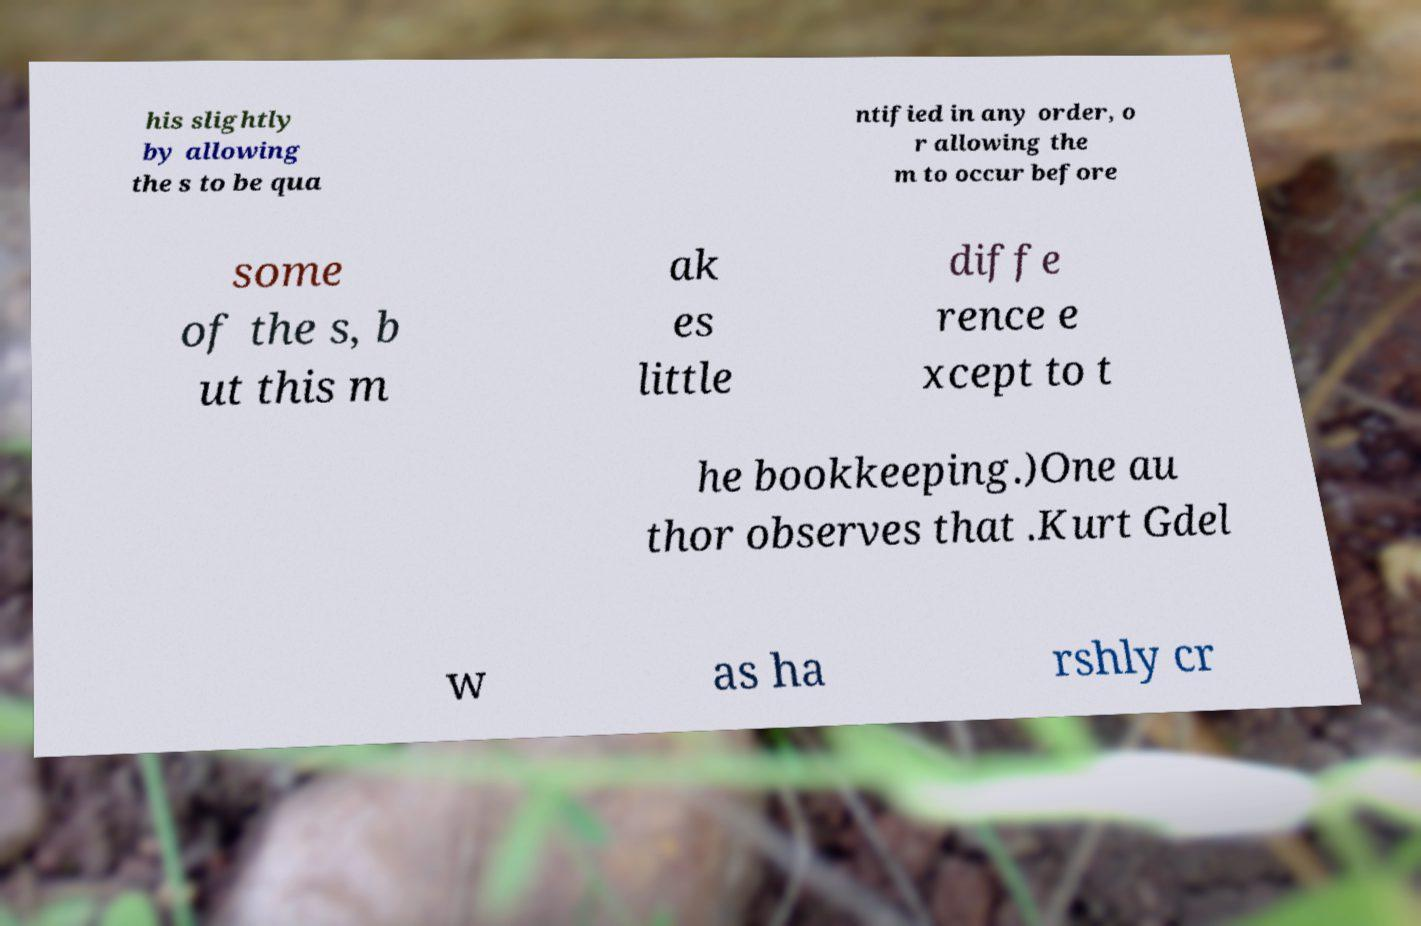What messages or text are displayed in this image? I need them in a readable, typed format. his slightly by allowing the s to be qua ntified in any order, o r allowing the m to occur before some of the s, b ut this m ak es little diffe rence e xcept to t he bookkeeping.)One au thor observes that .Kurt Gdel w as ha rshly cr 